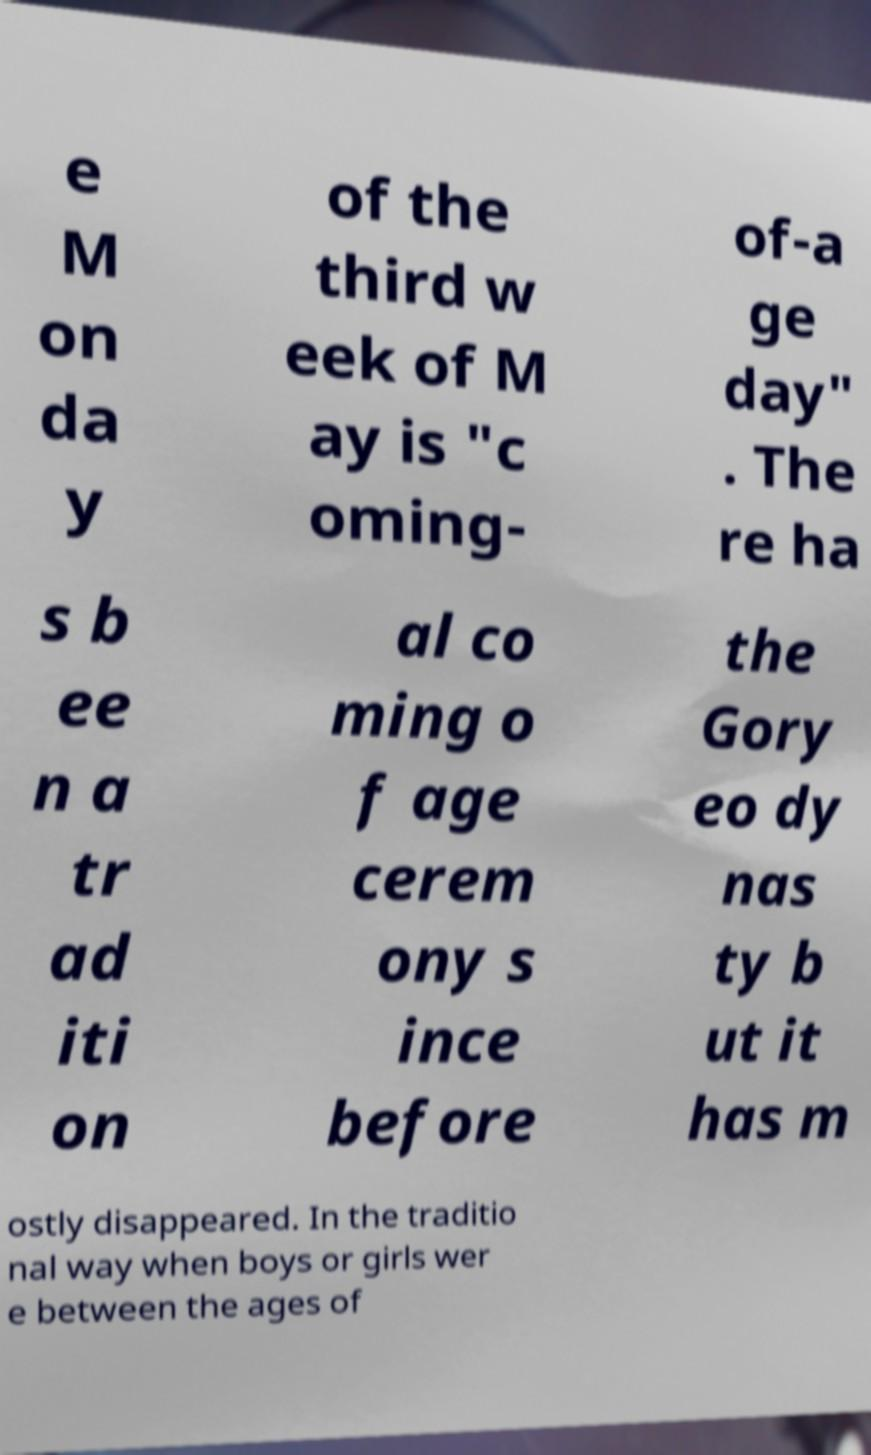There's text embedded in this image that I need extracted. Can you transcribe it verbatim? e M on da y of the third w eek of M ay is "c oming- of-a ge day" . The re ha s b ee n a tr ad iti on al co ming o f age cerem ony s ince before the Gory eo dy nas ty b ut it has m ostly disappeared. In the traditio nal way when boys or girls wer e between the ages of 